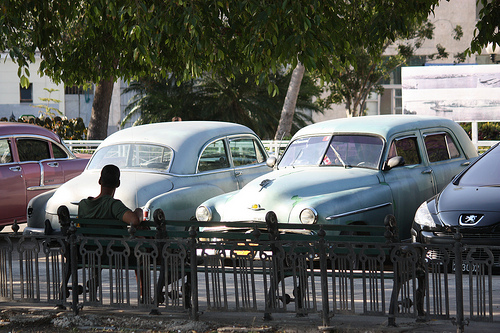<image>
Is the car behind the man? No. The car is not behind the man. From this viewpoint, the car appears to be positioned elsewhere in the scene. Is the man in the car? No. The man is not contained within the car. These objects have a different spatial relationship. 